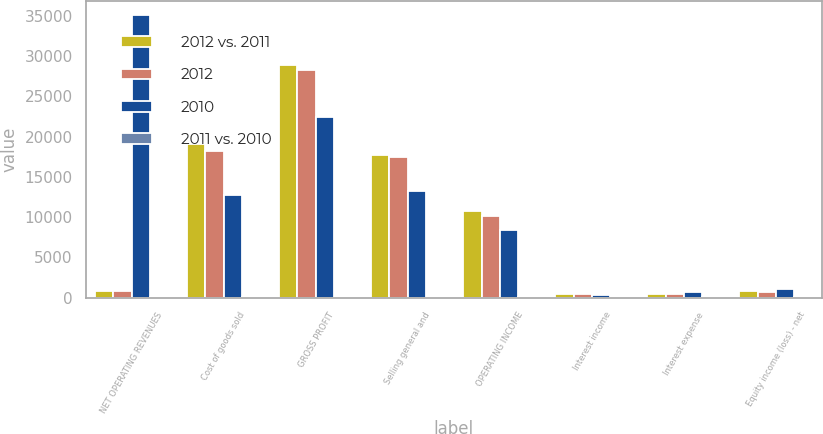<chart> <loc_0><loc_0><loc_500><loc_500><stacked_bar_chart><ecel><fcel>NET OPERATING REVENUES<fcel>Cost of goods sold<fcel>GROSS PROFIT<fcel>Selling general and<fcel>OPERATING INCOME<fcel>Interest income<fcel>Interest expense<fcel>Equity income (loss) - net<nl><fcel>2012 vs. 2011<fcel>776<fcel>19053<fcel>28964<fcel>17738<fcel>10779<fcel>471<fcel>397<fcel>819<nl><fcel>2012<fcel>776<fcel>18215<fcel>28327<fcel>17422<fcel>10173<fcel>483<fcel>417<fcel>690<nl><fcel>2010<fcel>35119<fcel>12693<fcel>22426<fcel>13194<fcel>8413<fcel>317<fcel>733<fcel>1025<nl><fcel>2011 vs. 2010<fcel>3<fcel>5<fcel>2<fcel>2<fcel>6<fcel>2<fcel>5<fcel>19<nl></chart> 